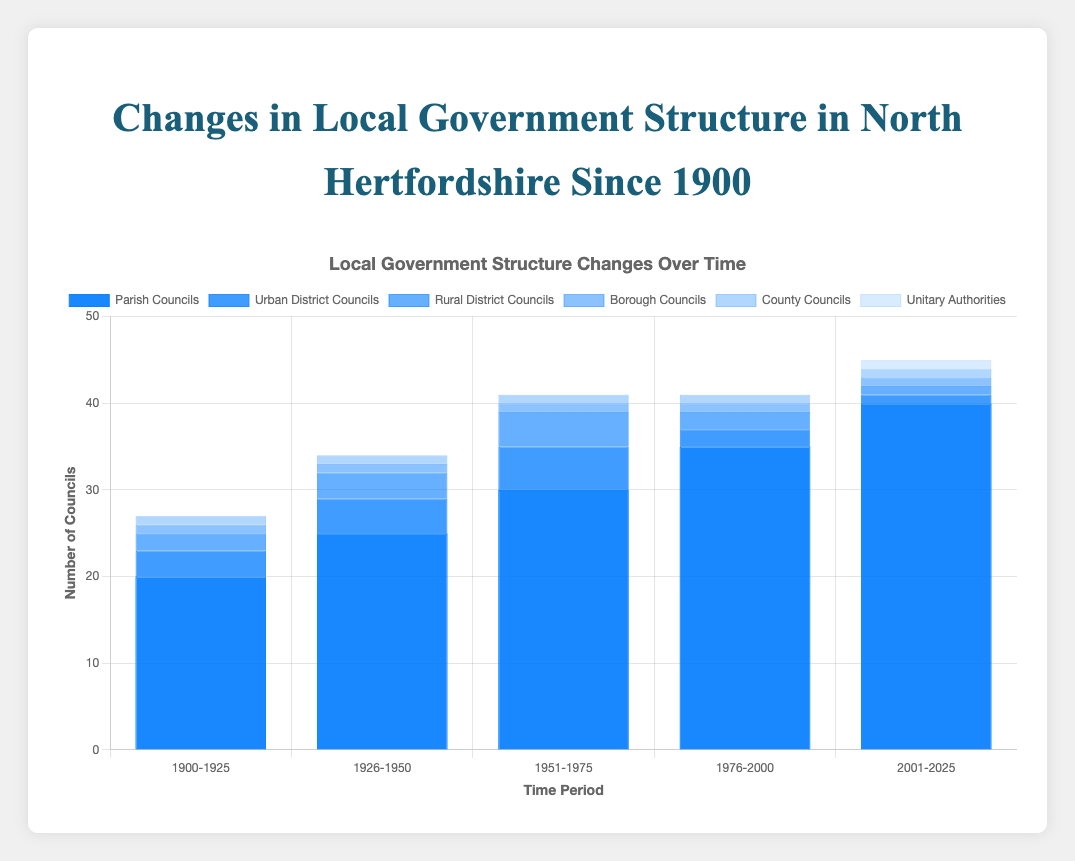What is the total number of Parish Councils from 1900 to 1925? According to the chart, the number of Parish Councils between 1900 and 1925 is 20.
Answer: 20 How has the number of Urban District Councils changed from 1951-1975 to 1976-2000? The number of Urban District Councils decreased from 5 in the period 1951-1975 to 2 in the period 1976-2000.
Answer: Decreased Which time period has the highest number of Parish Councils? The chart shows that the period 2001-2025 has the highest number of Parish Councils, which is 40.
Answer: 2001-2025 How many total councils (Parish, Urban District, Rural District, Borough, County, Unitary Authorities) exist in the period 2001-2025? Summing up all councils in the period 2001-2025: Parish Councils (40) + Urban District Councils (1) + Rural District Councils (1) + Borough Councils (1) + County Councils (1) + Unitary Authorities (1) = 45.
Answer: 45 Between which years does the number of Rural District Councils peak? The number of Rural District Councils peaks during the period 1951-1975, with 4 Rural District Councils.
Answer: 1951-1975 What is the combined number of Borough and County Councils from 1900-1925? The chart indicates there is 1 Borough Council and 1 County Council from 1900-1925, so combined they are 1 + 1 = 2.
Answer: 2 Which council type appeared for the first time in the period 2001-2025? The chart indicates that Unitary Authorities appeared for the first time in the period 2001-2025, with 1 Unitary Authority.
Answer: Unitary Authorities How does the number of Borough Councils compare over the given time periods? The number of Borough Councils remains constant at 1 for all the time periods from 1900 to 2025.
Answer: Constant What's the difference between the number of Parish Councils in the period 2001-2025 and the period 1900-1925? The number of Parish Councils in 2001-2025 is 40, and in 1900-1925 is 20. The difference is 40 - 20 = 20.
Answer: 20 